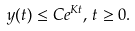Convert formula to latex. <formula><loc_0><loc_0><loc_500><loc_500>y ( t ) \leq C e ^ { K t } , \, t \geq 0 .</formula> 